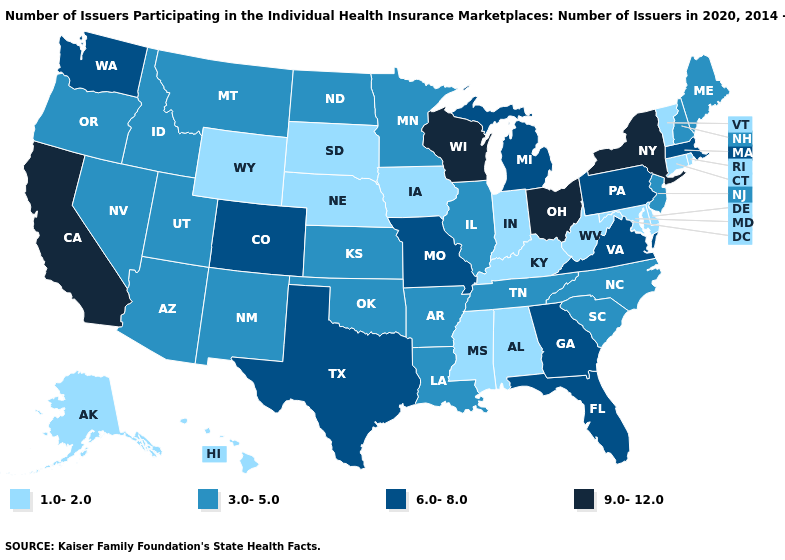What is the value of Tennessee?
Be succinct. 3.0-5.0. Does Kentucky have a lower value than South Dakota?
Quick response, please. No. Among the states that border Nevada , which have the lowest value?
Quick response, please. Arizona, Idaho, Oregon, Utah. What is the highest value in the USA?
Give a very brief answer. 9.0-12.0. Among the states that border Utah , which have the lowest value?
Keep it brief. Wyoming. How many symbols are there in the legend?
Be succinct. 4. Which states have the lowest value in the USA?
Give a very brief answer. Alabama, Alaska, Connecticut, Delaware, Hawaii, Indiana, Iowa, Kentucky, Maryland, Mississippi, Nebraska, Rhode Island, South Dakota, Vermont, West Virginia, Wyoming. Which states have the lowest value in the South?
Be succinct. Alabama, Delaware, Kentucky, Maryland, Mississippi, West Virginia. Name the states that have a value in the range 1.0-2.0?
Quick response, please. Alabama, Alaska, Connecticut, Delaware, Hawaii, Indiana, Iowa, Kentucky, Maryland, Mississippi, Nebraska, Rhode Island, South Dakota, Vermont, West Virginia, Wyoming. What is the lowest value in the South?
Keep it brief. 1.0-2.0. What is the highest value in states that border West Virginia?
Be succinct. 9.0-12.0. Does Nebraska have the highest value in the MidWest?
Concise answer only. No. Among the states that border Kentucky , which have the highest value?
Give a very brief answer. Ohio. Does Maryland have a higher value than New Mexico?
Keep it brief. No. What is the value of New Hampshire?
Short answer required. 3.0-5.0. 